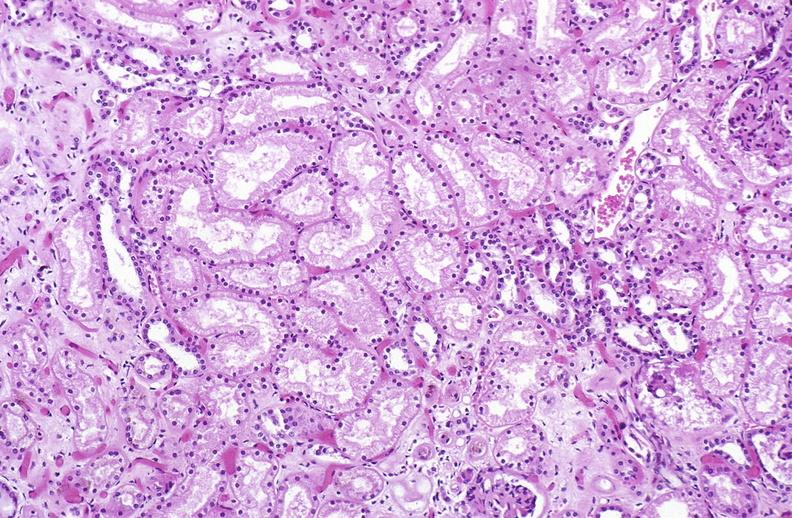does cm show atn acute tubular necrosis?
Answer the question using a single word or phrase. No 